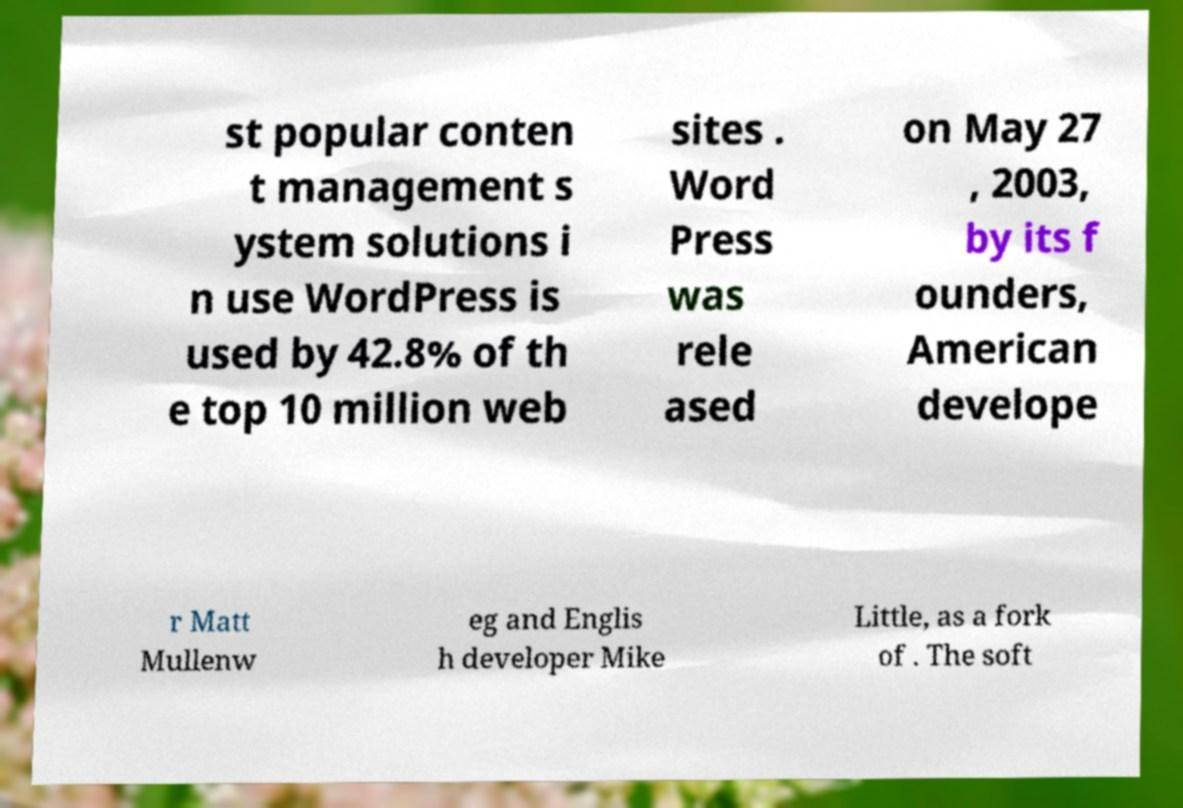I need the written content from this picture converted into text. Can you do that? st popular conten t management s ystem solutions i n use WordPress is used by 42.8% of th e top 10 million web sites . Word Press was rele ased on May 27 , 2003, by its f ounders, American develope r Matt Mullenw eg and Englis h developer Mike Little, as a fork of . The soft 